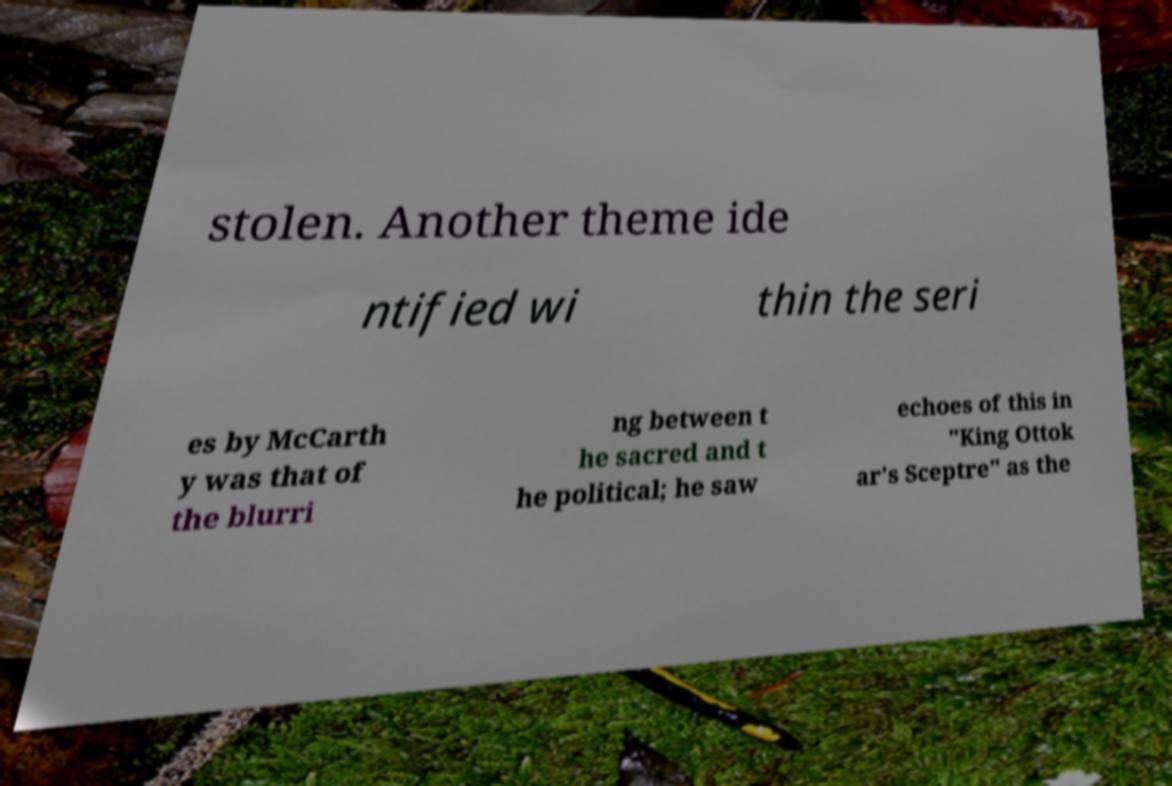There's text embedded in this image that I need extracted. Can you transcribe it verbatim? stolen. Another theme ide ntified wi thin the seri es by McCarth y was that of the blurri ng between t he sacred and t he political; he saw echoes of this in "King Ottok ar's Sceptre" as the 